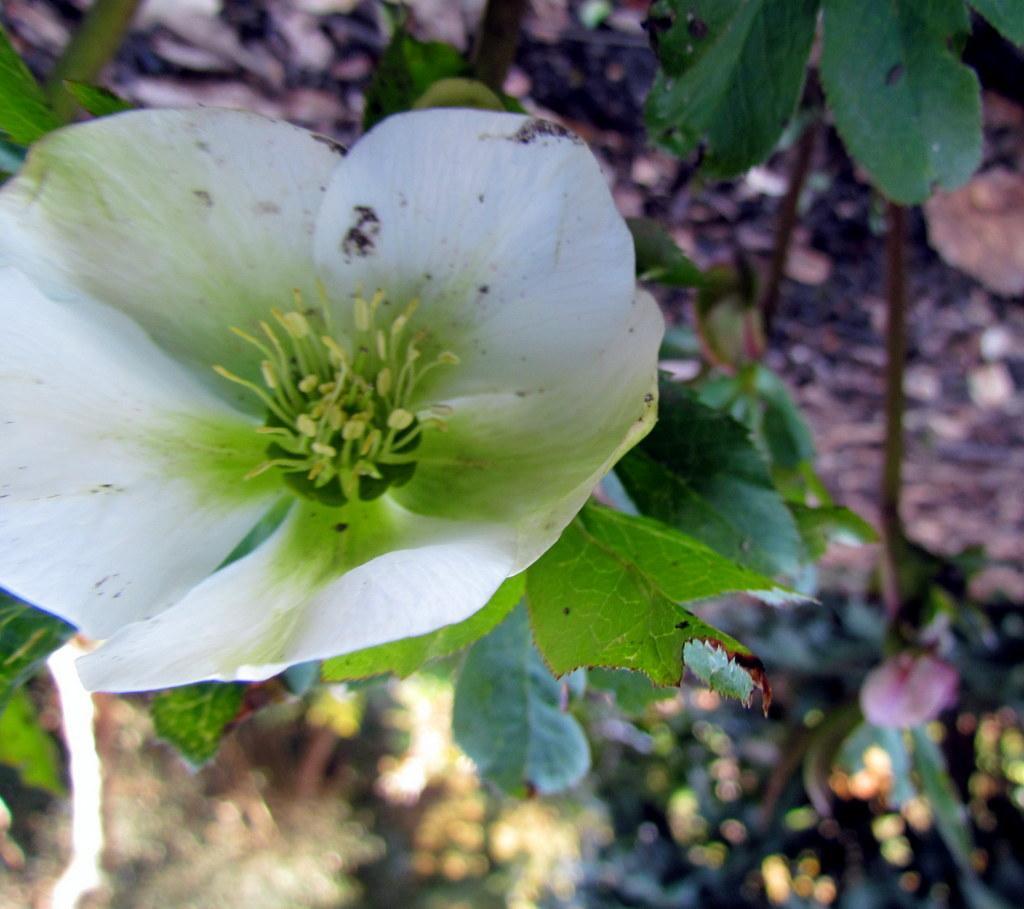Describe this image in one or two sentences. In this image, I can see a flower and leaves. There is a blurred background. 